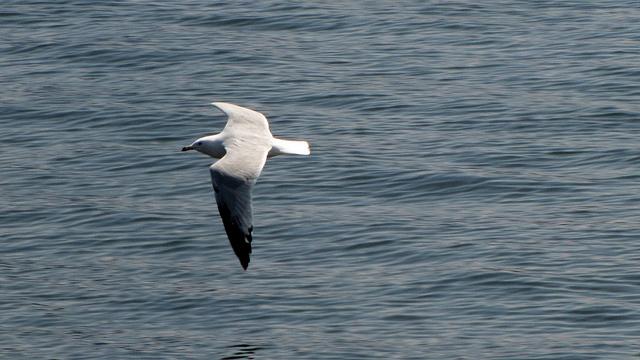Is this bird mid-flight?
Short answer required. Yes. How many birds are there?
Write a very short answer. 1. Is the bird flying?
Be succinct. Yes. How many different types of bird are in the image?
Give a very brief answer. 1. Is this a goose?
Concise answer only. No. What type of bird is this?
Answer briefly. Seagull. What is there a reflection of in the water?
Quick response, please. Bird. Is the bird flying above the water?
Give a very brief answer. Yes. What kind of bird is this?
Short answer required. Seagull. Is this a big swan?
Short answer required. No. Is the bird about to land?
Quick response, please. No. Where is the bird flying?
Write a very short answer. Over ocean. What kind of birds are in the water?
Answer briefly. Seagull. Is there foliage in the background?
Quick response, please. No. How many colors does the bird have?
Be succinct. 2. Does the bird have a large beak?
Quick response, please. No. How many birds are shown?
Give a very brief answer. 1. Is this seagull landing?
Write a very short answer. No. How many birds are flying?
Short answer required. 1. How many white birds are flying?
Answer briefly. 1. Are the birds in calm or rough waters?
Short answer required. Calm. 